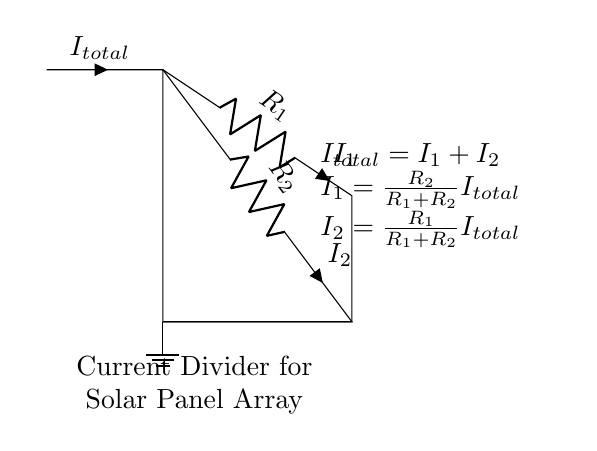What type of circuit is this? This circuit is classified as a current divider circuit, which is designed to divide total current into multiple branches based on the resistance values of those branches. The two resistors are connected in parallel, which is characteristic of a current divider.
Answer: Current divider What is the total current entering the circuit? The total current entering the circuit is denoted as total current, which is specified in the diagram as I total. It is the current that comes from the solar panel array before it splits into I one and I two.
Answer: I total Which components are used in the current branches? The components in the current branches are resistors. Specifically, the circuit diagram shows two resistors labeled R one and R two in the current divider.
Answer: R one and R two How do you calculate I one? I one is calculated using the formula provided in the circuit diagram: I one equals R two divided by the sum of R one and R two, multiplied by I total. This indicates how much current flows through resistor R one relative to the total current, based on the resistances.
Answer: R two over R one plus R two times I total What relationship does I one and I two have? The relationship between I one and I two is given by the equation I total equals I one plus I two. This shows that the total current flowing through the circuit is equal to the sum of the currents flowing through both resistors.
Answer: I total equals I one plus I two What does the ground symbol represent in this circuit? The ground symbol in this circuit represents the reference point for the electrical potential and serves as the return path for the current to complete the circuit. It signifies that the circuit is connected to the earth or a common return path.
Answer: Reference point 